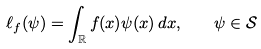Convert formula to latex. <formula><loc_0><loc_0><loc_500><loc_500>\ell _ { f } ( \psi ) = \int _ { \mathbb { R } } f ( x ) \psi ( x ) \, d x , \quad \psi \in \mathcal { S }</formula> 